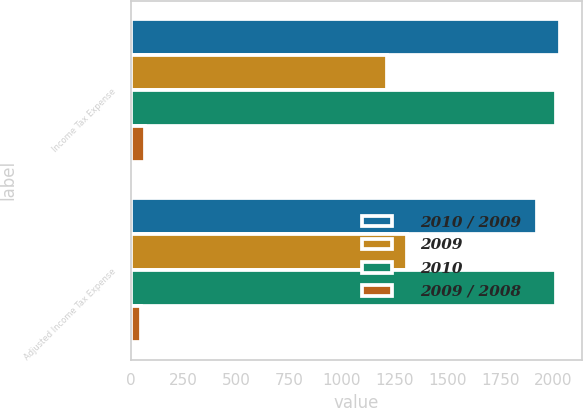Convert chart to OTSL. <chart><loc_0><loc_0><loc_500><loc_500><stacked_bar_chart><ecel><fcel>Income Tax Expense<fcel>Adjusted Income Tax Expense<nl><fcel>2010 / 2009<fcel>2035<fcel>1922<nl><fcel>2009<fcel>1214<fcel>1308<nl><fcel>2010<fcel>2012<fcel>2012<nl><fcel>2009 / 2008<fcel>67.6<fcel>46.9<nl></chart> 